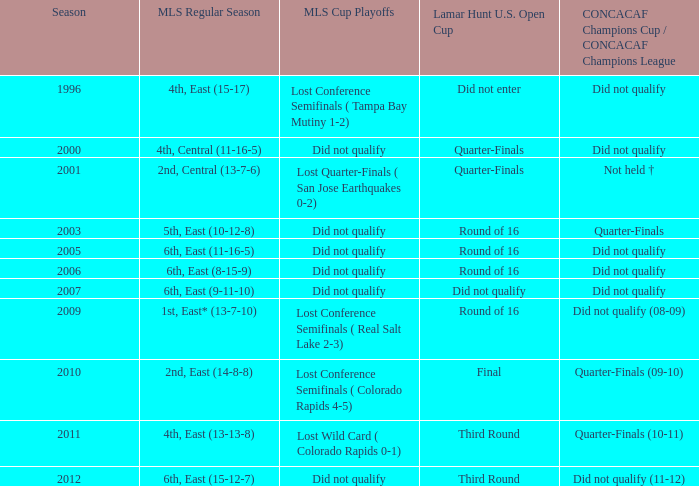How many mls cup playoffs were there for the mls regular season with the 1st place in the east having a 13-7-10 record? 1.0. 